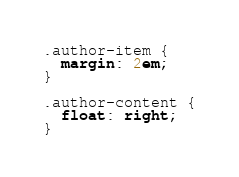<code> <loc_0><loc_0><loc_500><loc_500><_CSS_>.author-item {
  margin: 2em;
}

.author-content {
  float: right;
}
</code> 